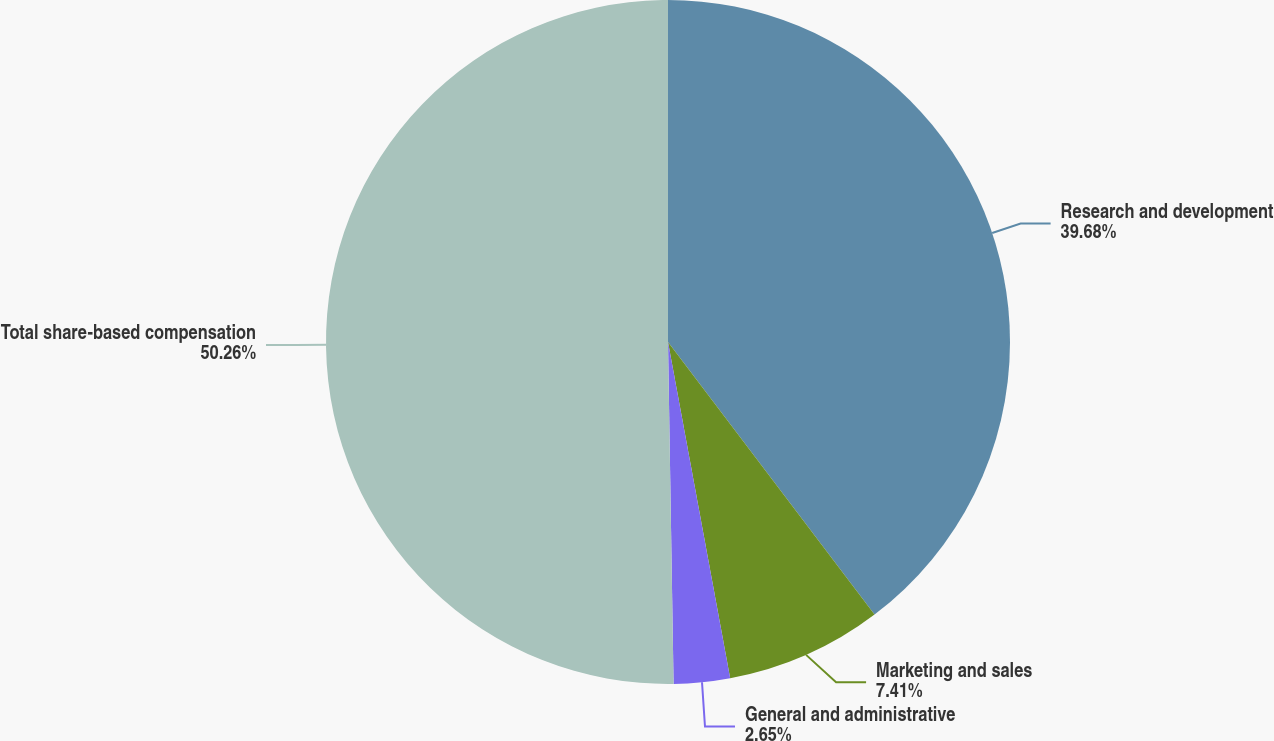<chart> <loc_0><loc_0><loc_500><loc_500><pie_chart><fcel>Research and development<fcel>Marketing and sales<fcel>General and administrative<fcel>Total share-based compensation<nl><fcel>39.68%<fcel>7.41%<fcel>2.65%<fcel>50.26%<nl></chart> 